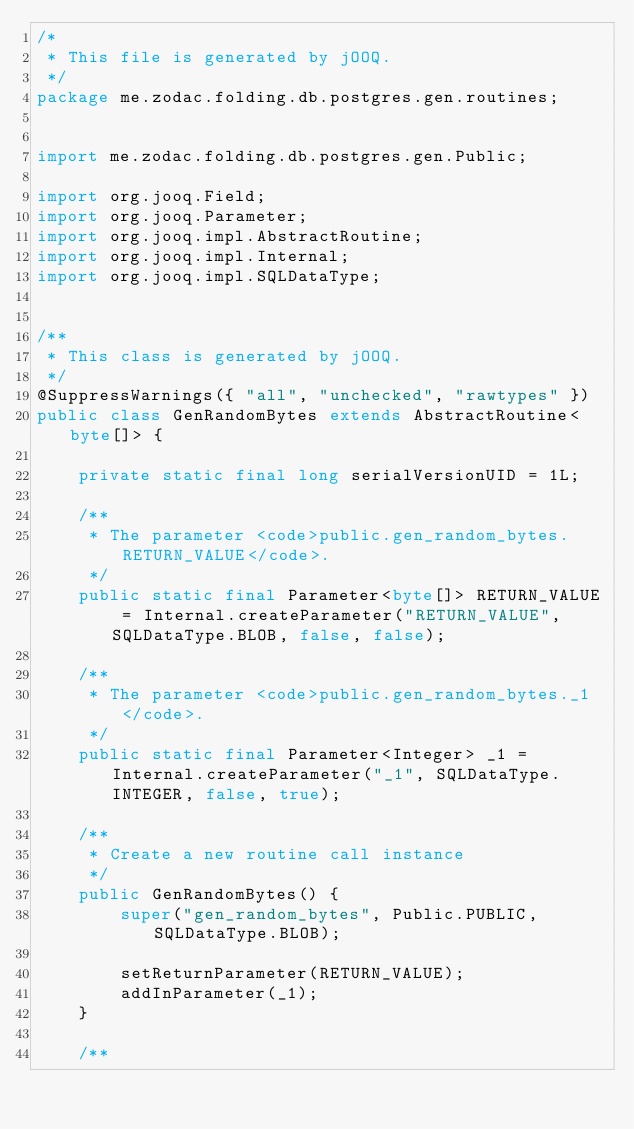Convert code to text. <code><loc_0><loc_0><loc_500><loc_500><_Java_>/*
 * This file is generated by jOOQ.
 */
package me.zodac.folding.db.postgres.gen.routines;


import me.zodac.folding.db.postgres.gen.Public;

import org.jooq.Field;
import org.jooq.Parameter;
import org.jooq.impl.AbstractRoutine;
import org.jooq.impl.Internal;
import org.jooq.impl.SQLDataType;


/**
 * This class is generated by jOOQ.
 */
@SuppressWarnings({ "all", "unchecked", "rawtypes" })
public class GenRandomBytes extends AbstractRoutine<byte[]> {

    private static final long serialVersionUID = 1L;

    /**
     * The parameter <code>public.gen_random_bytes.RETURN_VALUE</code>.
     */
    public static final Parameter<byte[]> RETURN_VALUE = Internal.createParameter("RETURN_VALUE", SQLDataType.BLOB, false, false);

    /**
     * The parameter <code>public.gen_random_bytes._1</code>.
     */
    public static final Parameter<Integer> _1 = Internal.createParameter("_1", SQLDataType.INTEGER, false, true);

    /**
     * Create a new routine call instance
     */
    public GenRandomBytes() {
        super("gen_random_bytes", Public.PUBLIC, SQLDataType.BLOB);

        setReturnParameter(RETURN_VALUE);
        addInParameter(_1);
    }

    /**</code> 